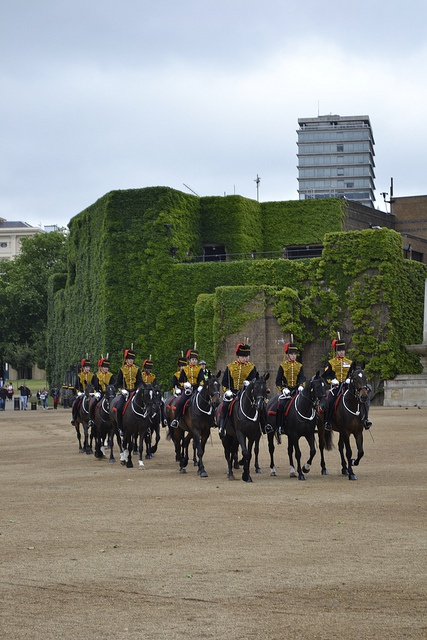Describe the objects in this image and their specific colors. I can see horse in lightblue, black, gray, darkgray, and maroon tones, horse in lightblue, black, gray, and darkgray tones, horse in lightblue, black, gray, maroon, and darkgray tones, horse in lightblue, black, gray, and darkgray tones, and horse in lightblue, black, gray, darkgray, and maroon tones in this image. 